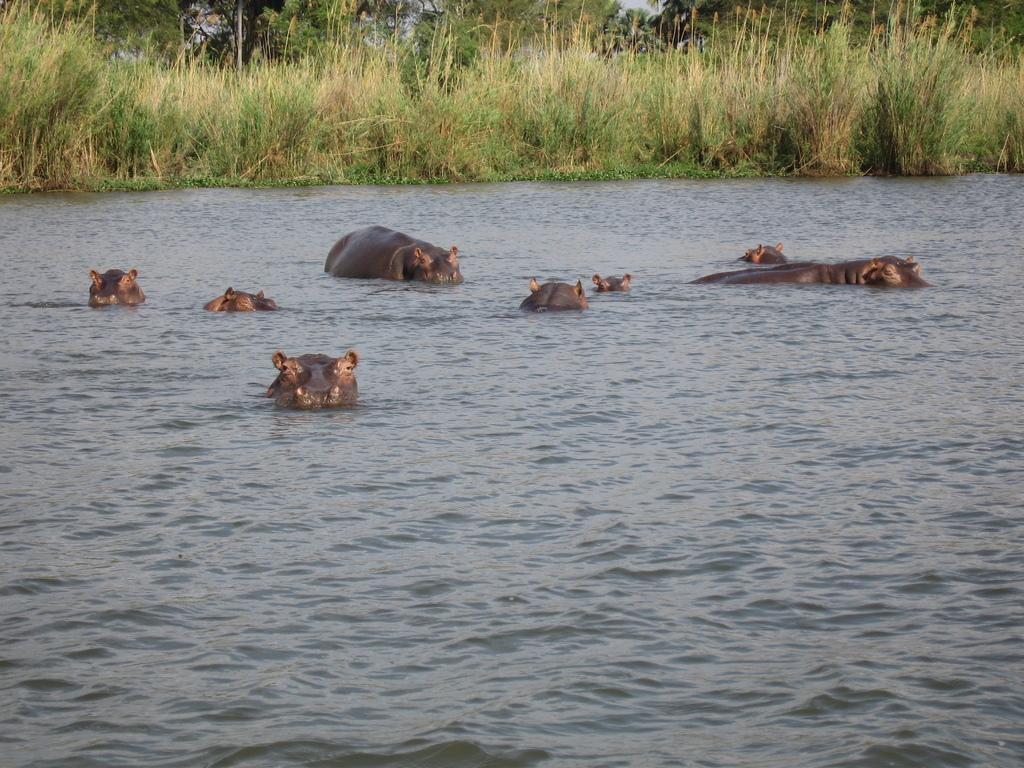What type of animals can be seen in the image? There are animals in the water. What can be seen in the background of the image? Grass and trees are visible in the background of the image. What type of teeth can be seen on the fairies in the image? There are no fairies present in the image, so there are no teeth to observe. 